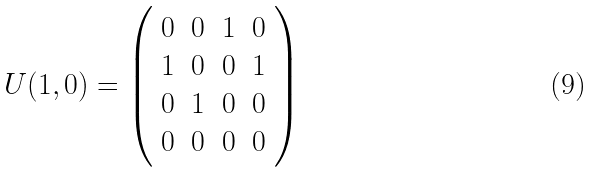<formula> <loc_0><loc_0><loc_500><loc_500>U ( 1 , 0 ) = \left ( \begin{array} { c c c c } 0 & 0 & 1 & 0 \\ 1 & 0 & 0 & 1 \\ 0 & 1 & 0 & 0 \\ 0 & 0 & 0 & 0 \end{array} \right )</formula> 